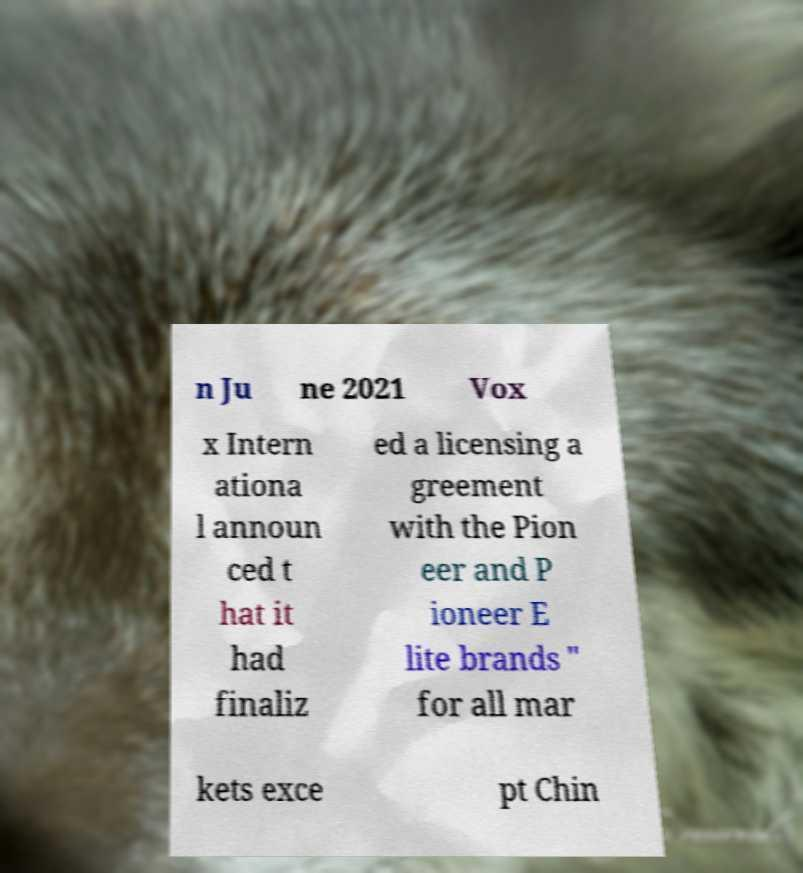For documentation purposes, I need the text within this image transcribed. Could you provide that? n Ju ne 2021 Vox x Intern ationa l announ ced t hat it had finaliz ed a licensing a greement with the Pion eer and P ioneer E lite brands " for all mar kets exce pt Chin 